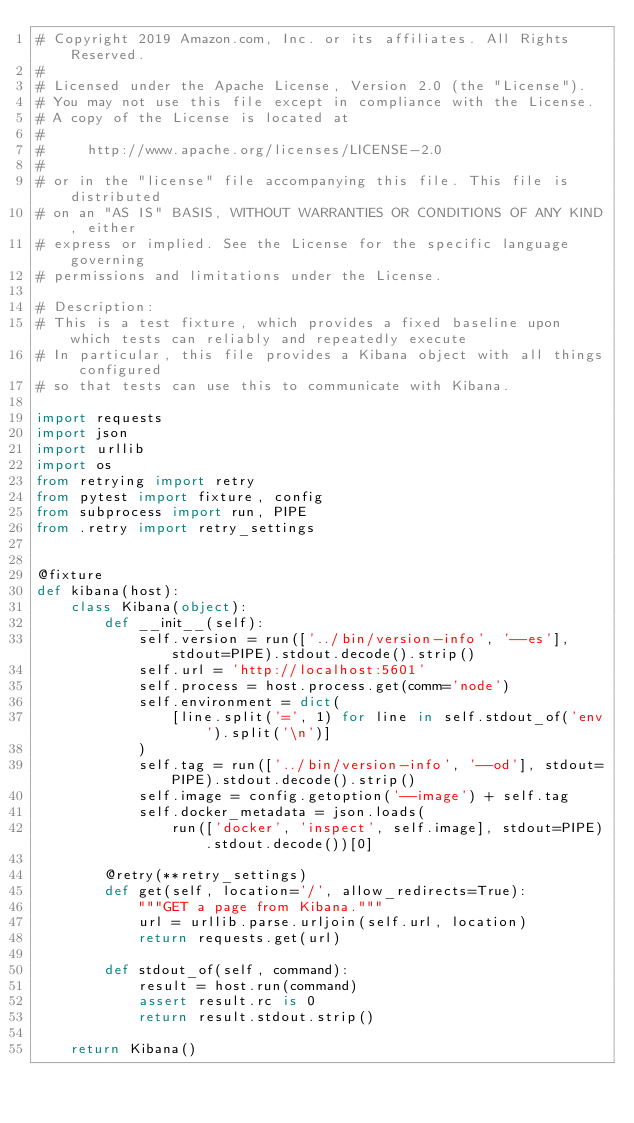<code> <loc_0><loc_0><loc_500><loc_500><_Python_># Copyright 2019 Amazon.com, Inc. or its affiliates. All Rights Reserved.
#
# Licensed under the Apache License, Version 2.0 (the "License").
# You may not use this file except in compliance with the License.
# A copy of the License is located at
#
#     http://www.apache.org/licenses/LICENSE-2.0
#
# or in the "license" file accompanying this file. This file is distributed
# on an "AS IS" BASIS, WITHOUT WARRANTIES OR CONDITIONS OF ANY KIND, either
# express or implied. See the License for the specific language governing
# permissions and limitations under the License.

# Description:
# This is a test fixture, which provides a fixed baseline upon which tests can reliably and repeatedly execute
# In particular, this file provides a Kibana object with all things configured
# so that tests can use this to communicate with Kibana.

import requests
import json
import urllib
import os
from retrying import retry
from pytest import fixture, config
from subprocess import run, PIPE
from .retry import retry_settings


@fixture
def kibana(host):
    class Kibana(object):
        def __init__(self):
            self.version = run(['../bin/version-info', '--es'], stdout=PIPE).stdout.decode().strip()
            self.url = 'http://localhost:5601'
            self.process = host.process.get(comm='node')
            self.environment = dict(
                [line.split('=', 1) for line in self.stdout_of('env').split('\n')]
            )
            self.tag = run(['../bin/version-info', '--od'], stdout=PIPE).stdout.decode().strip()
            self.image = config.getoption('--image') + self.tag
            self.docker_metadata = json.loads(
                run(['docker', 'inspect', self.image], stdout=PIPE).stdout.decode())[0]

        @retry(**retry_settings)
        def get(self, location='/', allow_redirects=True):
            """GET a page from Kibana."""
            url = urllib.parse.urljoin(self.url, location)
            return requests.get(url)

        def stdout_of(self, command):
            result = host.run(command)
            assert result.rc is 0
            return result.stdout.strip()

    return Kibana()
</code> 